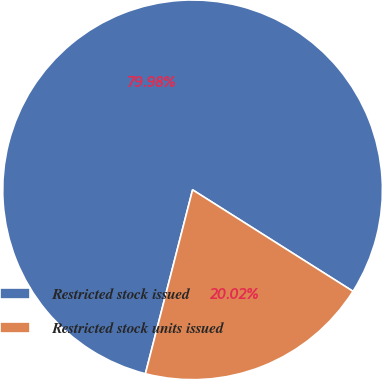<chart> <loc_0><loc_0><loc_500><loc_500><pie_chart><fcel>Restricted stock issued<fcel>Restricted stock units issued<nl><fcel>79.98%<fcel>20.02%<nl></chart> 